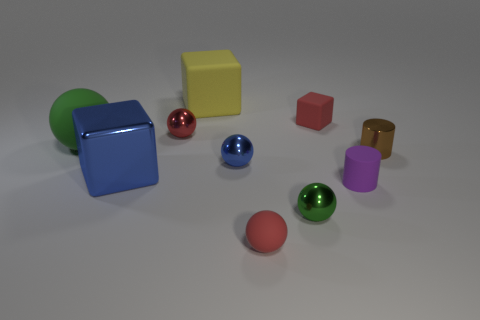Subtract all blue balls. How many balls are left? 4 Subtract all large balls. How many balls are left? 4 Subtract all yellow spheres. Subtract all green cubes. How many spheres are left? 5 Subtract all blocks. How many objects are left? 7 Add 4 small purple cylinders. How many small purple cylinders are left? 5 Add 9 gray cylinders. How many gray cylinders exist? 9 Subtract 0 gray cylinders. How many objects are left? 10 Subtract all yellow matte things. Subtract all green metal balls. How many objects are left? 8 